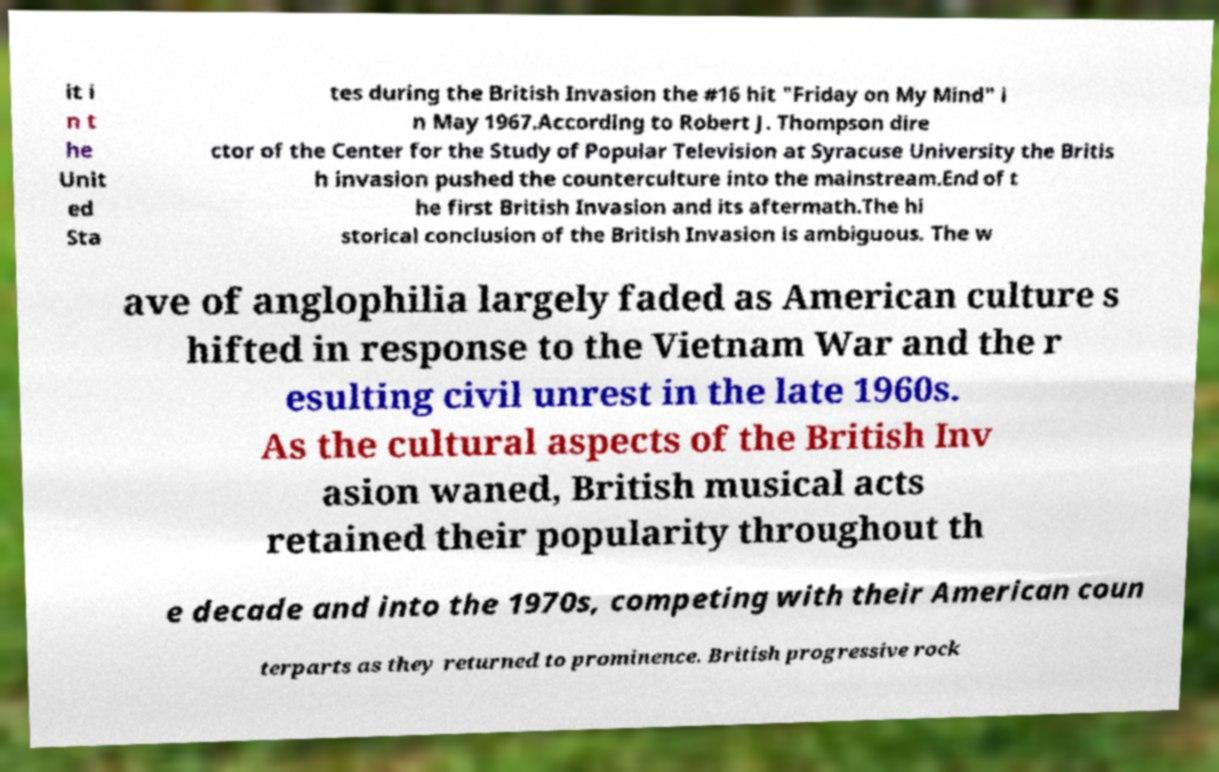Could you assist in decoding the text presented in this image and type it out clearly? it i n t he Unit ed Sta tes during the British Invasion the #16 hit "Friday on My Mind" i n May 1967.According to Robert J. Thompson dire ctor of the Center for the Study of Popular Television at Syracuse University the Britis h invasion pushed the counterculture into the mainstream.End of t he first British Invasion and its aftermath.The hi storical conclusion of the British Invasion is ambiguous. The w ave of anglophilia largely faded as American culture s hifted in response to the Vietnam War and the r esulting civil unrest in the late 1960s. As the cultural aspects of the British Inv asion waned, British musical acts retained their popularity throughout th e decade and into the 1970s, competing with their American coun terparts as they returned to prominence. British progressive rock 